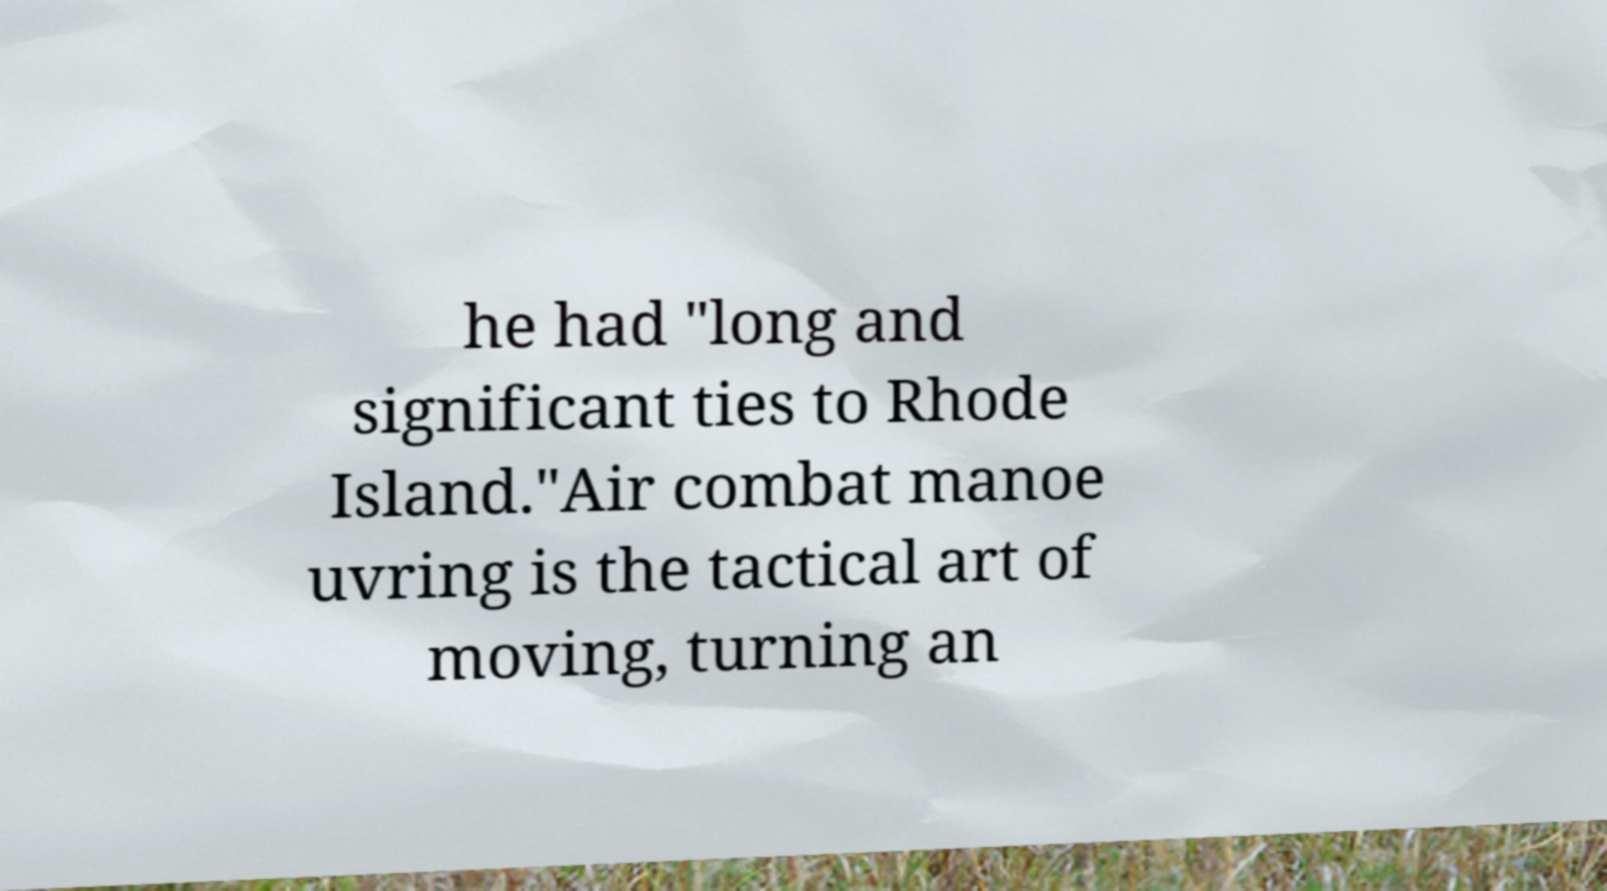What messages or text are displayed in this image? I need them in a readable, typed format. he had "long and significant ties to Rhode Island."Air combat manoe uvring is the tactical art of moving, turning an 